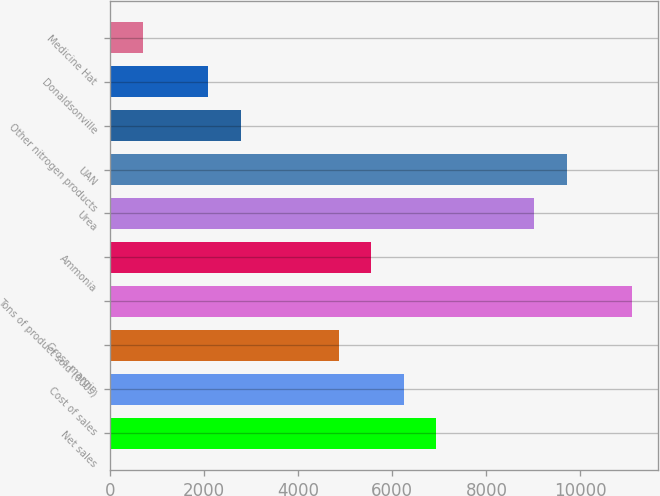Convert chart to OTSL. <chart><loc_0><loc_0><loc_500><loc_500><bar_chart><fcel>Net sales<fcel>Cost of sales<fcel>Gross margin<fcel>Tons of product sold (000s)<fcel>Ammonia<fcel>Urea<fcel>UAN<fcel>Other nitrogen products<fcel>Donaldsonville<fcel>Medicine Hat<nl><fcel>6937.99<fcel>6244.79<fcel>4858.39<fcel>11097.2<fcel>5551.59<fcel>9017.59<fcel>9710.79<fcel>2778.79<fcel>2085.59<fcel>699.19<nl></chart> 